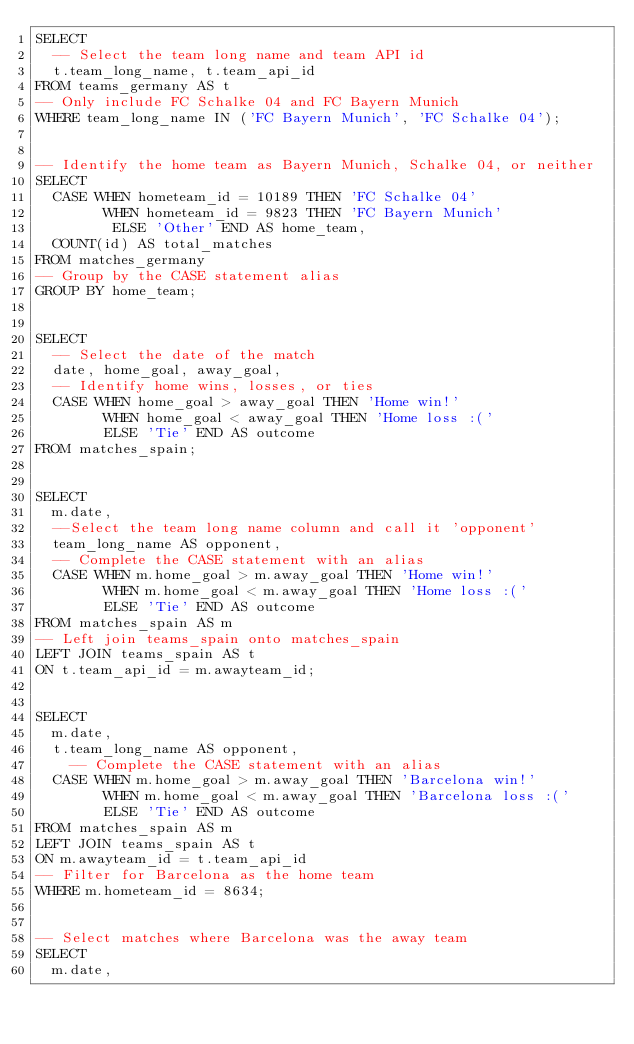<code> <loc_0><loc_0><loc_500><loc_500><_SQL_>SELECT
	-- Select the team long name and team API id
	t.team_long_name, t.team_api_id
FROM teams_germany AS t
-- Only include FC Schalke 04 and FC Bayern Munich
WHERE team_long_name IN ('FC Bayern Munich', 'FC Schalke 04');


-- Identify the home team as Bayern Munich, Schalke 04, or neither
SELECT 
	CASE WHEN hometeam_id = 10189 THEN 'FC Schalke 04'
        WHEN hometeam_id = 9823 THEN 'FC Bayern Munich'
         ELSE 'Other' END AS home_team,
	COUNT(id) AS total_matches
FROM matches_germany
-- Group by the CASE statement alias
GROUP BY home_team;


SELECT 
	-- Select the date of the match
	date, home_goal, away_goal,
	-- Identify home wins, losses, or ties
	CASE WHEN home_goal > away_goal THEN 'Home win!'
        WHEN home_goal < away_goal THEN 'Home loss :(' 
        ELSE 'Tie' END AS outcome
FROM matches_spain;


SELECT 
	m.date,
	--Select the team long name column and call it 'opponent'
	team_long_name AS opponent, 
	-- Complete the CASE statement with an alias
	CASE WHEN m.home_goal > m.away_goal THEN 'Home win!'
        WHEN m.home_goal < m.away_goal THEN 'Home loss :('
        ELSE 'Tie' END AS outcome
FROM matches_spain AS m
-- Left join teams_spain onto matches_spain
LEFT JOIN teams_spain AS t
ON t.team_api_id = m.awayteam_id;


SELECT 
	m.date,
	t.team_long_name AS opponent,
    -- Complete the CASE statement with an alias
	CASE WHEN m.home_goal > m.away_goal THEN 'Barcelona win!'
        WHEN m.home_goal < m.away_goal THEN 'Barcelona loss :(' 
        ELSE 'Tie' END AS outcome 
FROM matches_spain AS m
LEFT JOIN teams_spain AS t 
ON m.awayteam_id = t.team_api_id
-- Filter for Barcelona as the home team
WHERE m.hometeam_id = 8634; 


-- Select matches where Barcelona was the away team
SELECT  
	m.date,</code> 